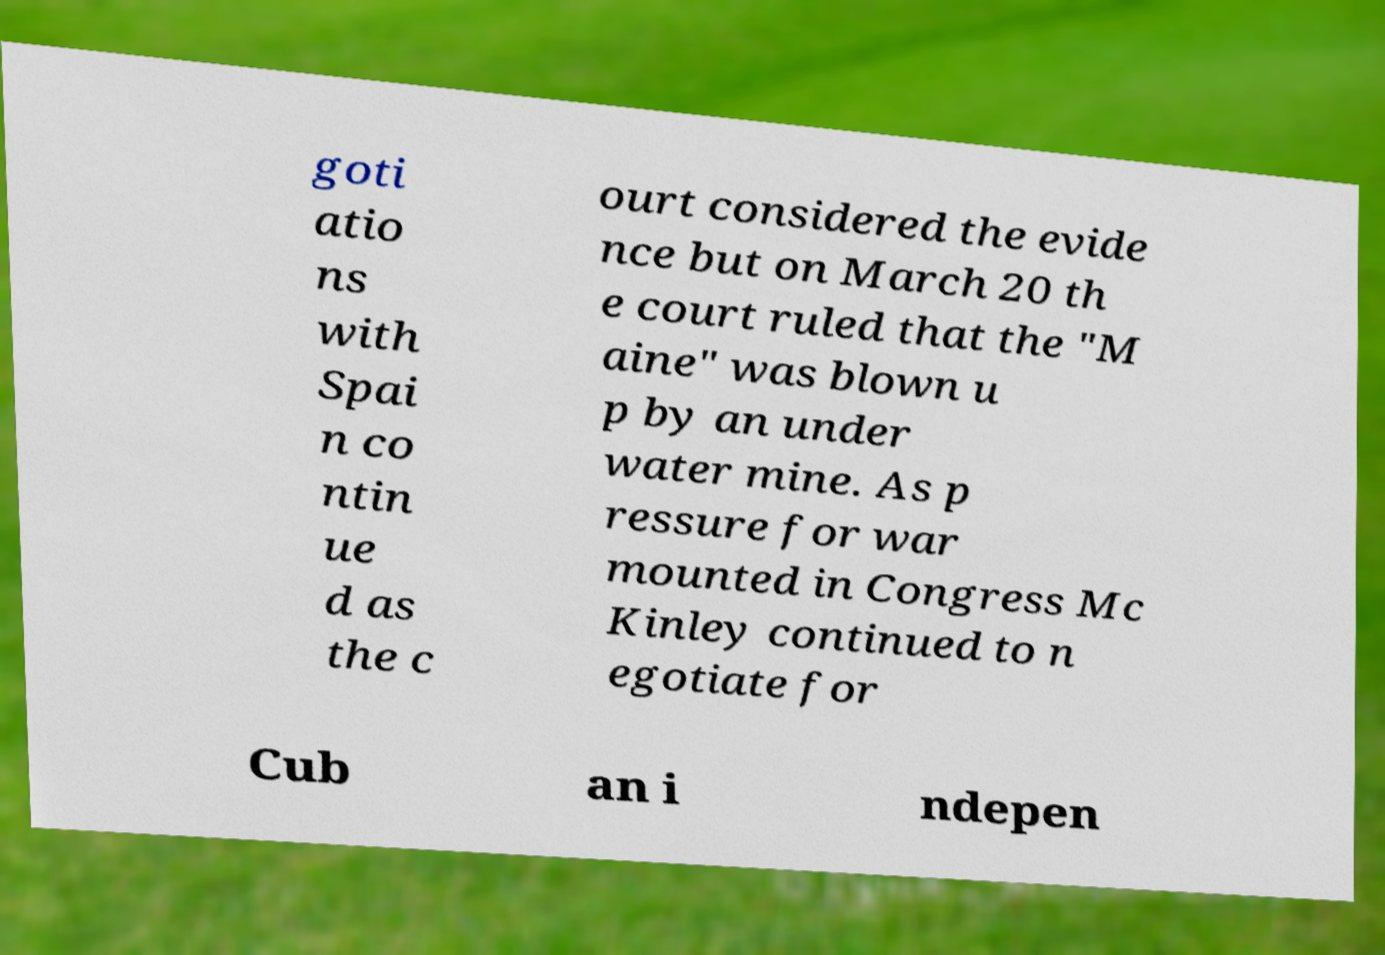I need the written content from this picture converted into text. Can you do that? goti atio ns with Spai n co ntin ue d as the c ourt considered the evide nce but on March 20 th e court ruled that the "M aine" was blown u p by an under water mine. As p ressure for war mounted in Congress Mc Kinley continued to n egotiate for Cub an i ndepen 